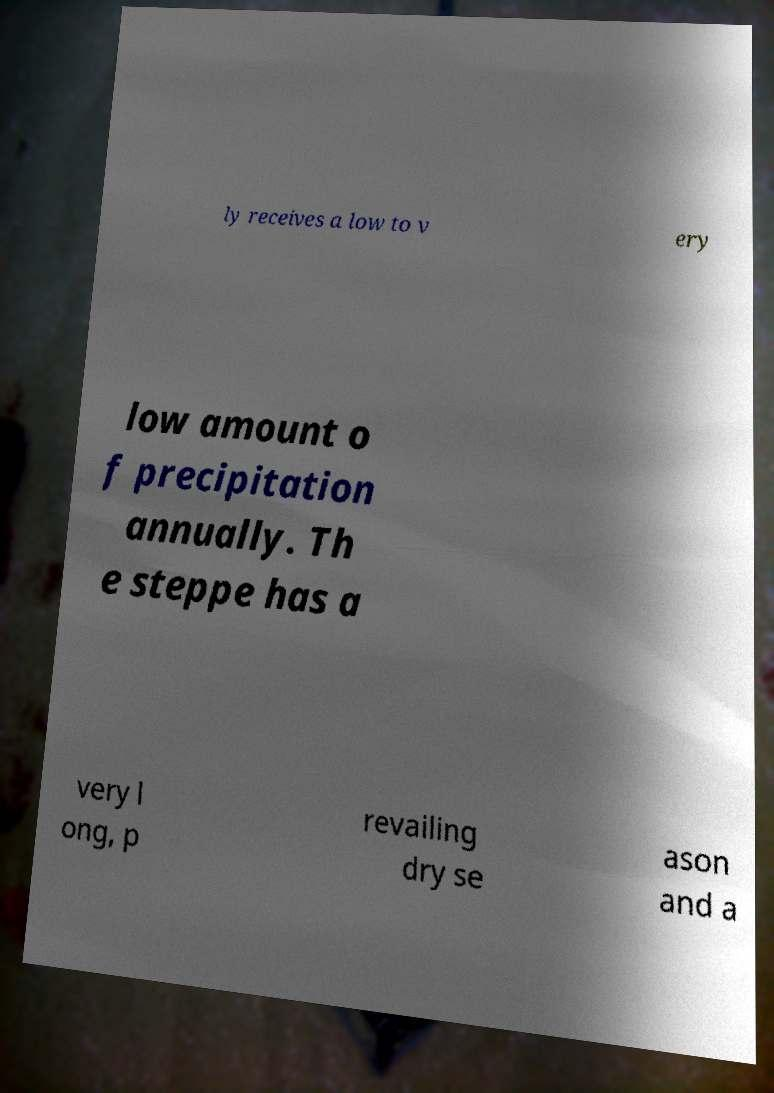Please read and relay the text visible in this image. What does it say? ly receives a low to v ery low amount o f precipitation annually. Th e steppe has a very l ong, p revailing dry se ason and a 